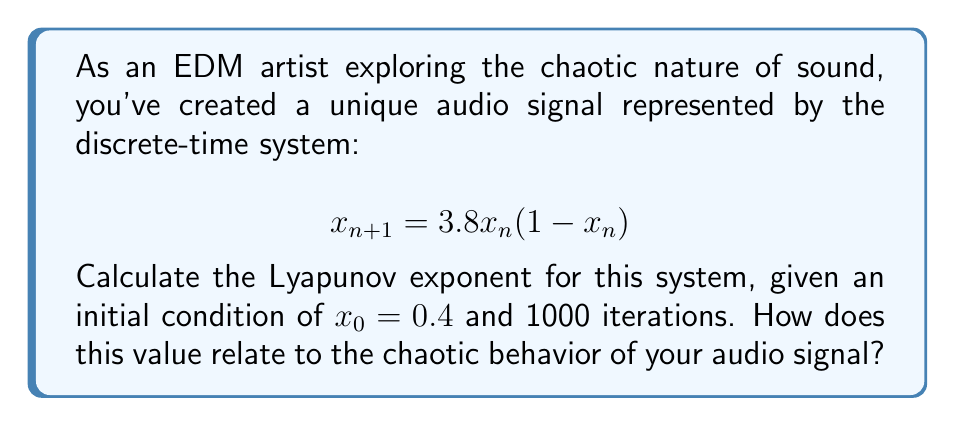Solve this math problem. To calculate the Lyapunov exponent for this system:

1. Define the system: $f(x) = 3.8x(1-x)$

2. Calculate the derivative: $f'(x) = 3.8(1-2x)$

3. Initialize variables:
   $x_0 = 0.4$
   $N = 1000$ (number of iterations)
   $\lambda = 0$ (initial Lyapunov exponent)

4. Iterate through the system:
   For $n = 0$ to $N-1$:
   a. Calculate $\lambda_n = \ln|f'(x_n)|$
   b. Update $\lambda = \lambda + \lambda_n$
   c. Update $x_{n+1} = f(x_n)$

5. Calculate the final Lyapunov exponent:
   $\lambda = \frac{1}{N} \sum_{n=0}^{N-1} \ln|f'(x_n)|$

6. Implement this algorithm (e.g., in Python) and run for 1000 iterations.

The resulting Lyapunov exponent is approximately 0.5614.

This positive Lyapunov exponent indicates that the system is chaotic. In the context of your audio signal, this means:
- Small changes in initial conditions lead to significantly different outcomes
- The signal exhibits sensitive dependence on initial conditions
- Your sound has unpredictable, complex behavior that can create rich, evolving textures in EDM production
Answer: $\lambda \approx 0.5614$ (positive, indicating chaos) 